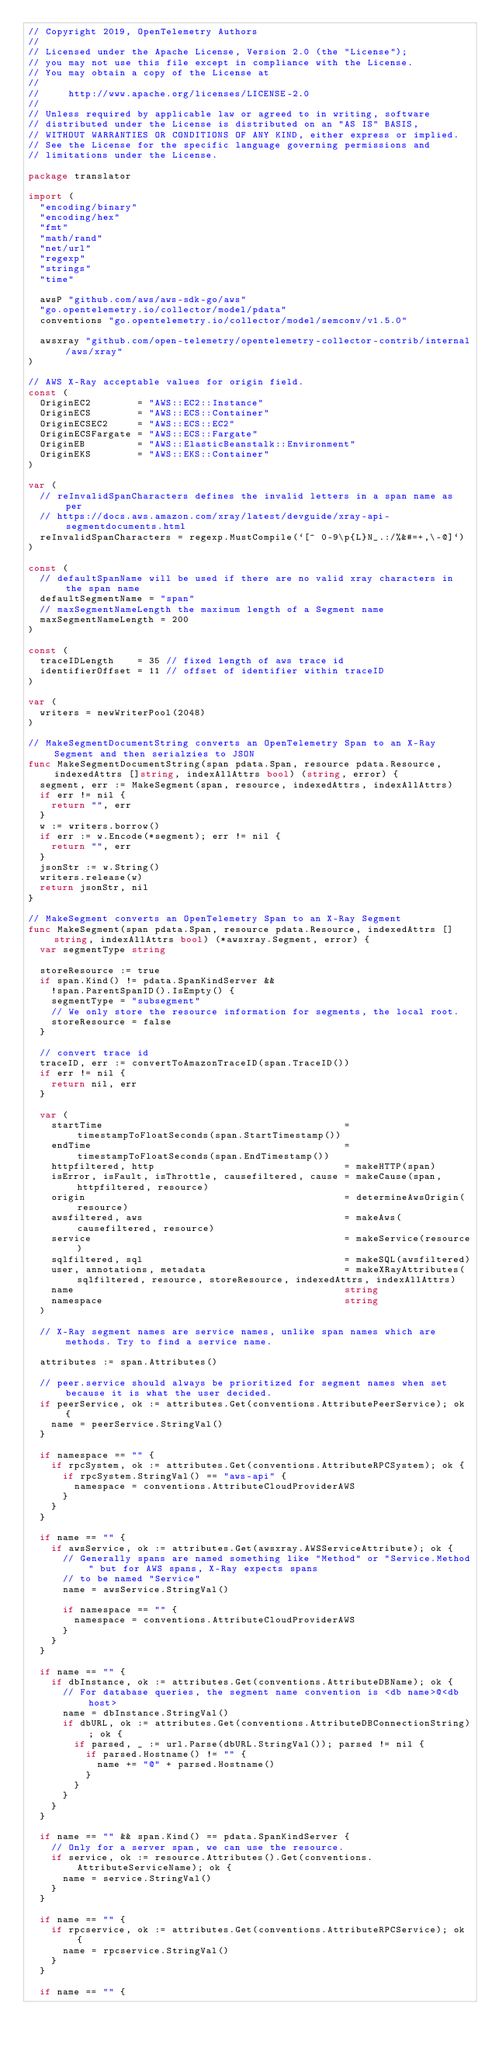<code> <loc_0><loc_0><loc_500><loc_500><_Go_>// Copyright 2019, OpenTelemetry Authors
//
// Licensed under the Apache License, Version 2.0 (the "License");
// you may not use this file except in compliance with the License.
// You may obtain a copy of the License at
//
//     http://www.apache.org/licenses/LICENSE-2.0
//
// Unless required by applicable law or agreed to in writing, software
// distributed under the License is distributed on an "AS IS" BASIS,
// WITHOUT WARRANTIES OR CONDITIONS OF ANY KIND, either express or implied.
// See the License for the specific language governing permissions and
// limitations under the License.

package translator

import (
	"encoding/binary"
	"encoding/hex"
	"fmt"
	"math/rand"
	"net/url"
	"regexp"
	"strings"
	"time"

	awsP "github.com/aws/aws-sdk-go/aws"
	"go.opentelemetry.io/collector/model/pdata"
	conventions "go.opentelemetry.io/collector/model/semconv/v1.5.0"

	awsxray "github.com/open-telemetry/opentelemetry-collector-contrib/internal/aws/xray"
)

// AWS X-Ray acceptable values for origin field.
const (
	OriginEC2        = "AWS::EC2::Instance"
	OriginECS        = "AWS::ECS::Container"
	OriginECSEC2     = "AWS::ECS::EC2"
	OriginECSFargate = "AWS::ECS::Fargate"
	OriginEB         = "AWS::ElasticBeanstalk::Environment"
	OriginEKS        = "AWS::EKS::Container"
)

var (
	// reInvalidSpanCharacters defines the invalid letters in a span name as per
	// https://docs.aws.amazon.com/xray/latest/devguide/xray-api-segmentdocuments.html
	reInvalidSpanCharacters = regexp.MustCompile(`[^ 0-9\p{L}N_.:/%&#=+,\-@]`)
)

const (
	// defaultSpanName will be used if there are no valid xray characters in the span name
	defaultSegmentName = "span"
	// maxSegmentNameLength the maximum length of a Segment name
	maxSegmentNameLength = 200
)

const (
	traceIDLength    = 35 // fixed length of aws trace id
	identifierOffset = 11 // offset of identifier within traceID
)

var (
	writers = newWriterPool(2048)
)

// MakeSegmentDocumentString converts an OpenTelemetry Span to an X-Ray Segment and then serialzies to JSON
func MakeSegmentDocumentString(span pdata.Span, resource pdata.Resource, indexedAttrs []string, indexAllAttrs bool) (string, error) {
	segment, err := MakeSegment(span, resource, indexedAttrs, indexAllAttrs)
	if err != nil {
		return "", err
	}
	w := writers.borrow()
	if err := w.Encode(*segment); err != nil {
		return "", err
	}
	jsonStr := w.String()
	writers.release(w)
	return jsonStr, nil
}

// MakeSegment converts an OpenTelemetry Span to an X-Ray Segment
func MakeSegment(span pdata.Span, resource pdata.Resource, indexedAttrs []string, indexAllAttrs bool) (*awsxray.Segment, error) {
	var segmentType string

	storeResource := true
	if span.Kind() != pdata.SpanKindServer &&
		!span.ParentSpanID().IsEmpty() {
		segmentType = "subsegment"
		// We only store the resource information for segments, the local root.
		storeResource = false
	}

	// convert trace id
	traceID, err := convertToAmazonTraceID(span.TraceID())
	if err != nil {
		return nil, err
	}

	var (
		startTime                                          = timestampToFloatSeconds(span.StartTimestamp())
		endTime                                            = timestampToFloatSeconds(span.EndTimestamp())
		httpfiltered, http                                 = makeHTTP(span)
		isError, isFault, isThrottle, causefiltered, cause = makeCause(span, httpfiltered, resource)
		origin                                             = determineAwsOrigin(resource)
		awsfiltered, aws                                   = makeAws(causefiltered, resource)
		service                                            = makeService(resource)
		sqlfiltered, sql                                   = makeSQL(awsfiltered)
		user, annotations, metadata                        = makeXRayAttributes(sqlfiltered, resource, storeResource, indexedAttrs, indexAllAttrs)
		name                                               string
		namespace                                          string
	)

	// X-Ray segment names are service names, unlike span names which are methods. Try to find a service name.

	attributes := span.Attributes()

	// peer.service should always be prioritized for segment names when set because it is what the user decided.
	if peerService, ok := attributes.Get(conventions.AttributePeerService); ok {
		name = peerService.StringVal()
	}

	if namespace == "" {
		if rpcSystem, ok := attributes.Get(conventions.AttributeRPCSystem); ok {
			if rpcSystem.StringVal() == "aws-api" {
				namespace = conventions.AttributeCloudProviderAWS
			}
		}
	}

	if name == "" {
		if awsService, ok := attributes.Get(awsxray.AWSServiceAttribute); ok {
			// Generally spans are named something like "Method" or "Service.Method" but for AWS spans, X-Ray expects spans
			// to be named "Service"
			name = awsService.StringVal()

			if namespace == "" {
				namespace = conventions.AttributeCloudProviderAWS
			}
		}
	}

	if name == "" {
		if dbInstance, ok := attributes.Get(conventions.AttributeDBName); ok {
			// For database queries, the segment name convention is <db name>@<db host>
			name = dbInstance.StringVal()
			if dbURL, ok := attributes.Get(conventions.AttributeDBConnectionString); ok {
				if parsed, _ := url.Parse(dbURL.StringVal()); parsed != nil {
					if parsed.Hostname() != "" {
						name += "@" + parsed.Hostname()
					}
				}
			}
		}
	}

	if name == "" && span.Kind() == pdata.SpanKindServer {
		// Only for a server span, we can use the resource.
		if service, ok := resource.Attributes().Get(conventions.AttributeServiceName); ok {
			name = service.StringVal()
		}
	}

	if name == "" {
		if rpcservice, ok := attributes.Get(conventions.AttributeRPCService); ok {
			name = rpcservice.StringVal()
		}
	}

	if name == "" {</code> 